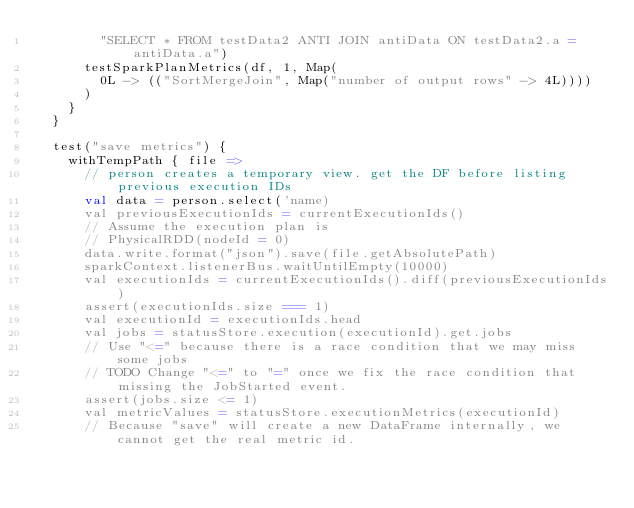Convert code to text. <code><loc_0><loc_0><loc_500><loc_500><_Scala_>        "SELECT * FROM testData2 ANTI JOIN antiData ON testData2.a = antiData.a")
      testSparkPlanMetrics(df, 1, Map(
        0L -> (("SortMergeJoin", Map("number of output rows" -> 4L))))
      )
    }
  }

  test("save metrics") {
    withTempPath { file =>
      // person creates a temporary view. get the DF before listing previous execution IDs
      val data = person.select('name)
      val previousExecutionIds = currentExecutionIds()
      // Assume the execution plan is
      // PhysicalRDD(nodeId = 0)
      data.write.format("json").save(file.getAbsolutePath)
      sparkContext.listenerBus.waitUntilEmpty(10000)
      val executionIds = currentExecutionIds().diff(previousExecutionIds)
      assert(executionIds.size === 1)
      val executionId = executionIds.head
      val jobs = statusStore.execution(executionId).get.jobs
      // Use "<=" because there is a race condition that we may miss some jobs
      // TODO Change "<=" to "=" once we fix the race condition that missing the JobStarted event.
      assert(jobs.size <= 1)
      val metricValues = statusStore.executionMetrics(executionId)
      // Because "save" will create a new DataFrame internally, we cannot get the real metric id.</code> 